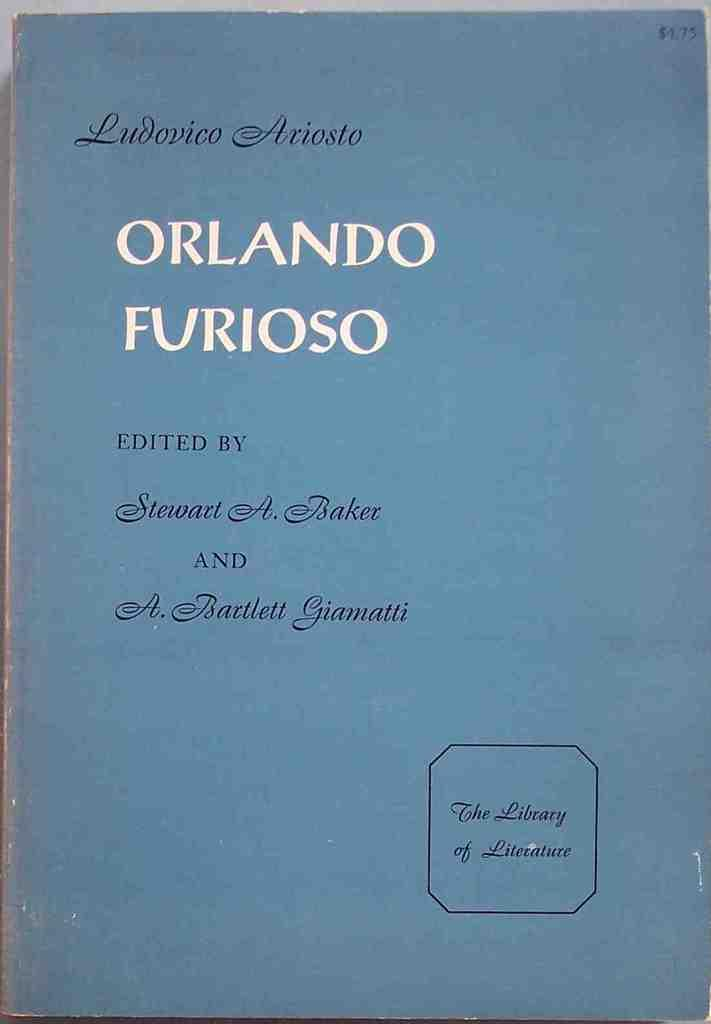<image>
Describe the image concisely. An old blue book cover titled Orlando Furioso. 